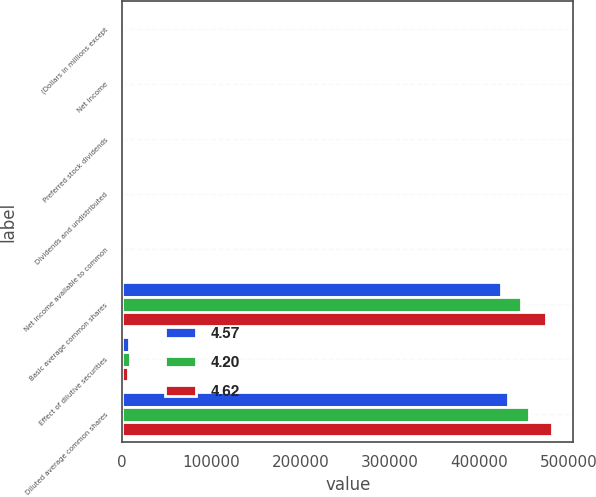Convert chart to OTSL. <chart><loc_0><loc_0><loc_500><loc_500><stacked_bar_chart><ecel><fcel>(Dollars in millions except<fcel>Net income<fcel>Preferred stock dividends<fcel>Dividends and undistributed<fcel>Net income available to common<fcel>Basic average common shares<fcel>Effect of dilutive securities<fcel>Diluted average common shares<nl><fcel>4.57<fcel>2014<fcel>2037<fcel>61<fcel>3<fcel>1973<fcel>424223<fcel>7784<fcel>432007<nl><fcel>4.2<fcel>2013<fcel>2136<fcel>26<fcel>8<fcel>2102<fcel>446245<fcel>8910<fcel>455155<nl><fcel>4.62<fcel>2012<fcel>2061<fcel>29<fcel>13<fcel>2019<fcel>474458<fcel>6671<fcel>481129<nl></chart> 